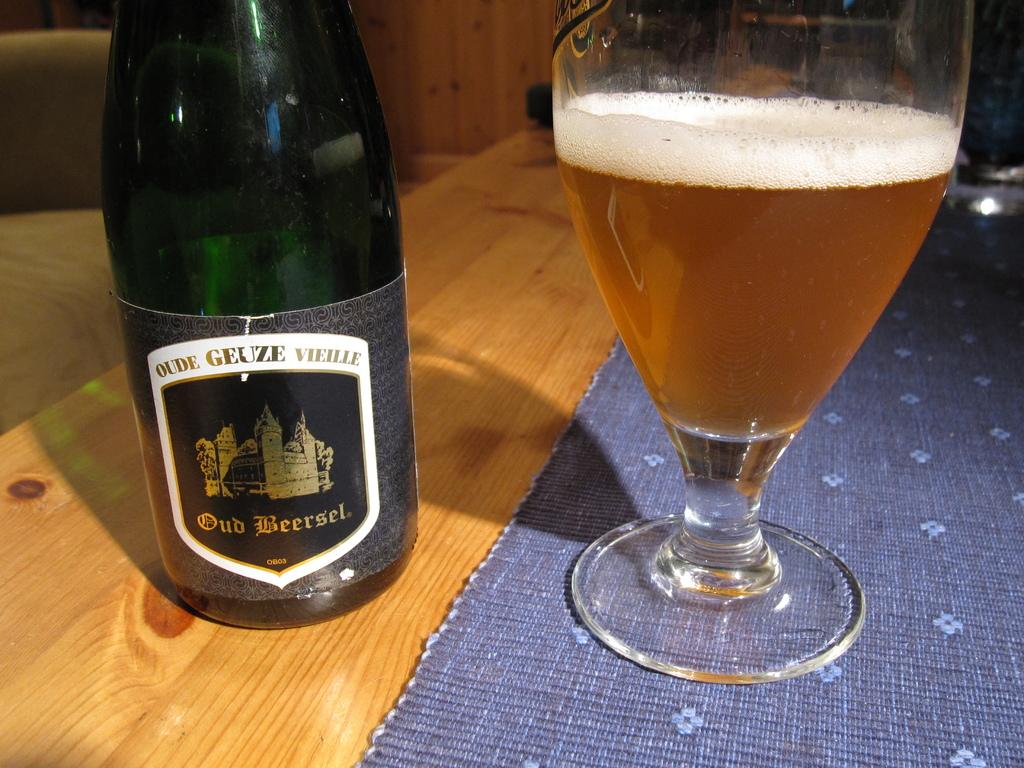<image>
Offer a succinct explanation of the picture presented. A bottle of Old Beersel sits next to a clear glass with the poured drink inside. 